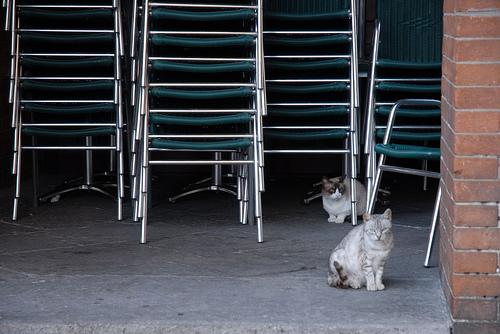If a few more of these animals appear here what would they be called?

Choices:
A) herd
B) school
C) pack
D) clowder clowder 